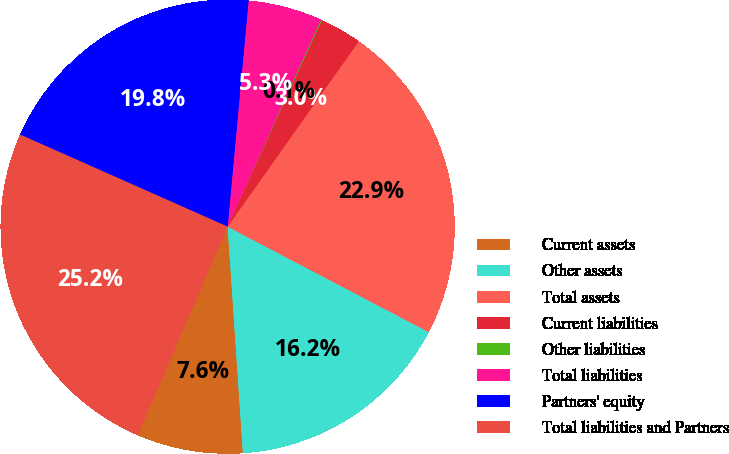Convert chart to OTSL. <chart><loc_0><loc_0><loc_500><loc_500><pie_chart><fcel>Current assets<fcel>Other assets<fcel>Total assets<fcel>Current liabilities<fcel>Other liabilities<fcel>Total liabilities<fcel>Partners' equity<fcel>Total liabilities and Partners<nl><fcel>7.55%<fcel>16.24%<fcel>22.88%<fcel>2.99%<fcel>0.07%<fcel>5.27%<fcel>19.82%<fcel>25.16%<nl></chart> 